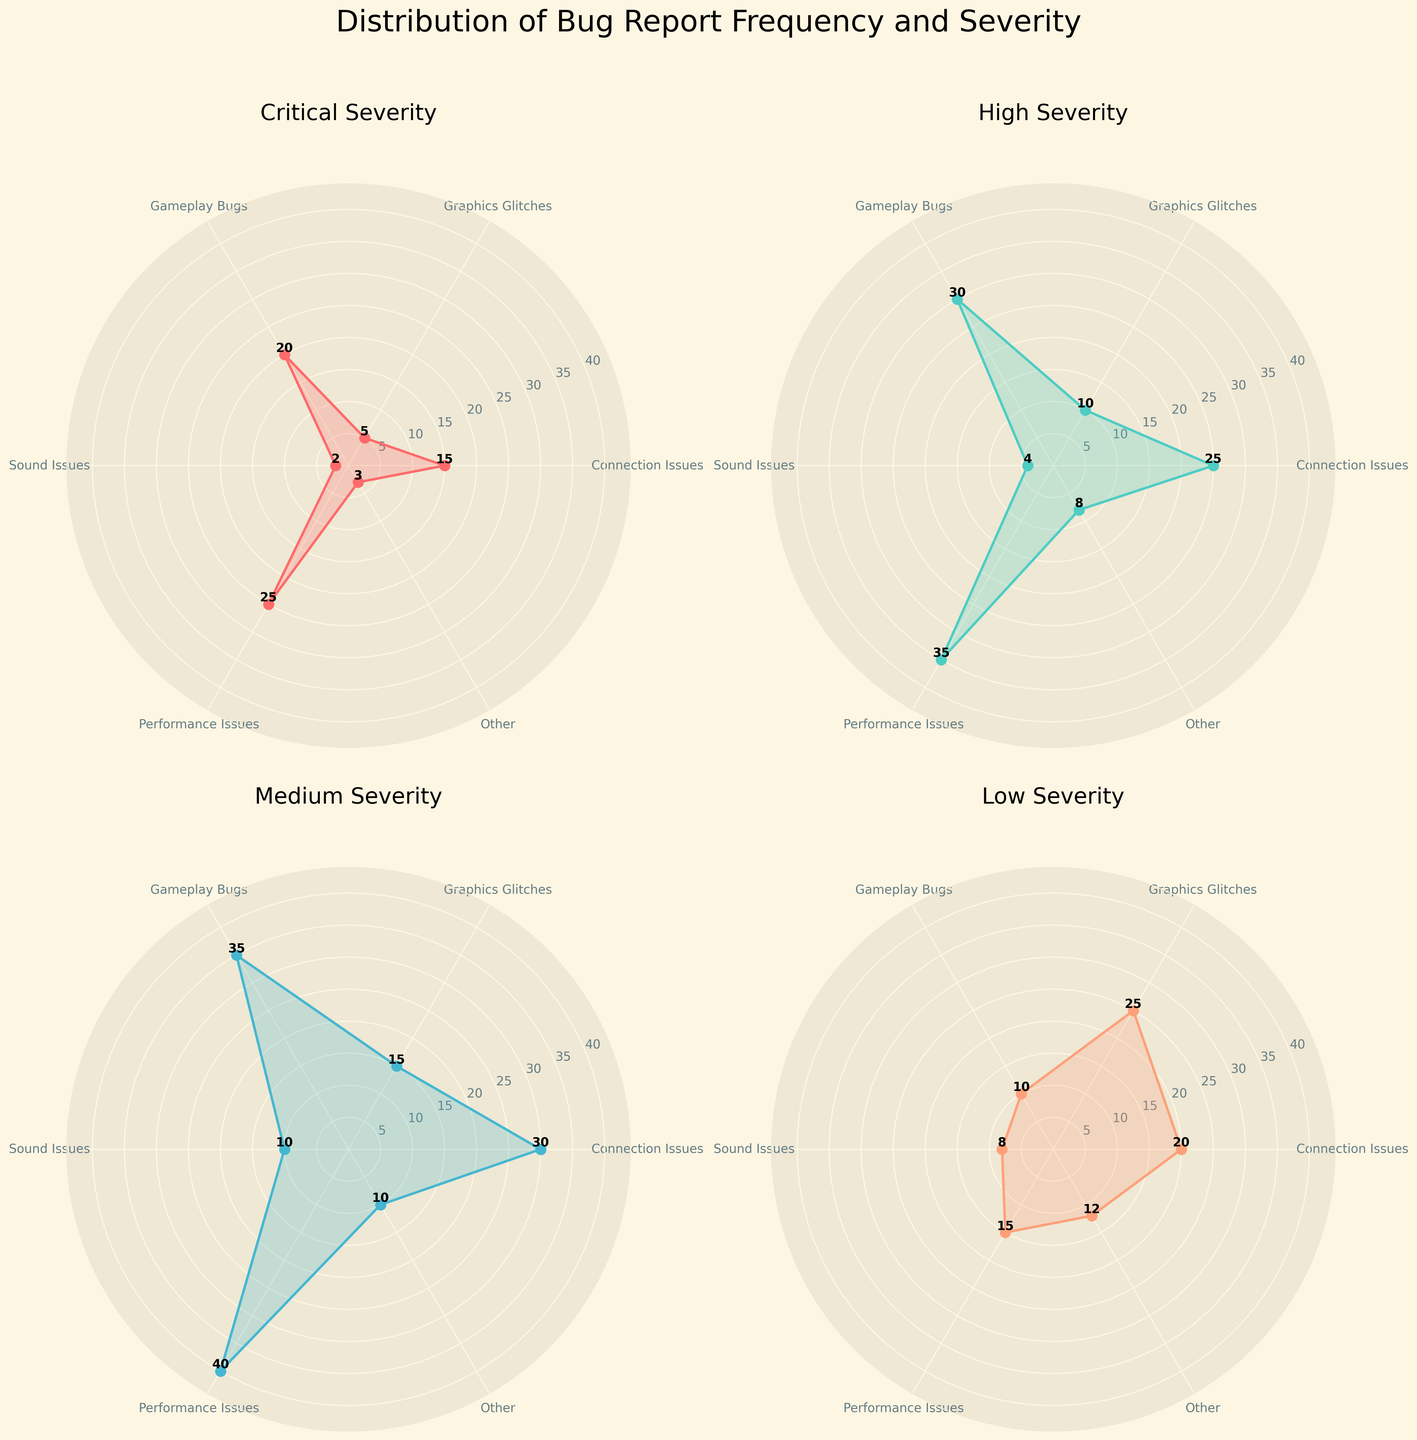Which category has the highest number of "Critical" severity reports? The "Critical" severity plot shows values for each category. "Performance Issues" has the highest value at 25.
Answer: Performance Issues What is the total number of "High" severity bug reports? Sum the values for each category in the "High" severity plot: 25 (Connection Issues) + 10 (Graphics Glitches) + 30 (Gameplay Bugs) + 4 (Sound Issues) + 35 (Performance Issues) + 8 (Other). The total is 25 + 10 + 30 + 4 + 35 + 8 = 112.
Answer: 112 Which severity category has the least number of reports for "Sound Issues"? By examining each severity plot, the "Critical" severity category has the least number of reports for "Sound Issues" with a value of 2.
Answer: Critical For "Medium" severity, which bug category has exactly 10 reports? By observing the "Medium" severity plot, "Sound Issues" has exactly 10 reports.
Answer: Sound Issues Compare "Low" severity reports for "Graphics Glitches" and "Performance Issues"; which one is less, and by how much? In the "Low" severity plot, "Graphics Glitches" has 25 reports and "Performance Issues" has 15 reports. The difference is 25 - 15 = 10.
Answer: Performance Issues by 10 What are the average number of reports for "Critical" severity across all categories? Sum the reports in the "Critical" severity plot and divide by the number of categories: (15 + 5 + 20 + 2 + 25 + 3) / 6 = 70 / 6 ≈ 11.67.
Answer: 11.67 Identify the category with the highest variance in bug report severity distribution. The variance is determined by the spread of values across different severity levels. "Connection Issues" ranges from 15 (Critical) to 30 (Medium), showing considerable variance, while "Performance Issues" ranges from 15 (Low) to 40 (Medium), thus having the highest variance.
Answer: Performance Issues What is the combined total of "Gameplay Bugs" reports for "Critical" and "High" severities? Sum the "Gameplay Bugs" values for "Critical" and "High" severities: 20 (Critical) + 30 (High) = 50.
Answer: 50 